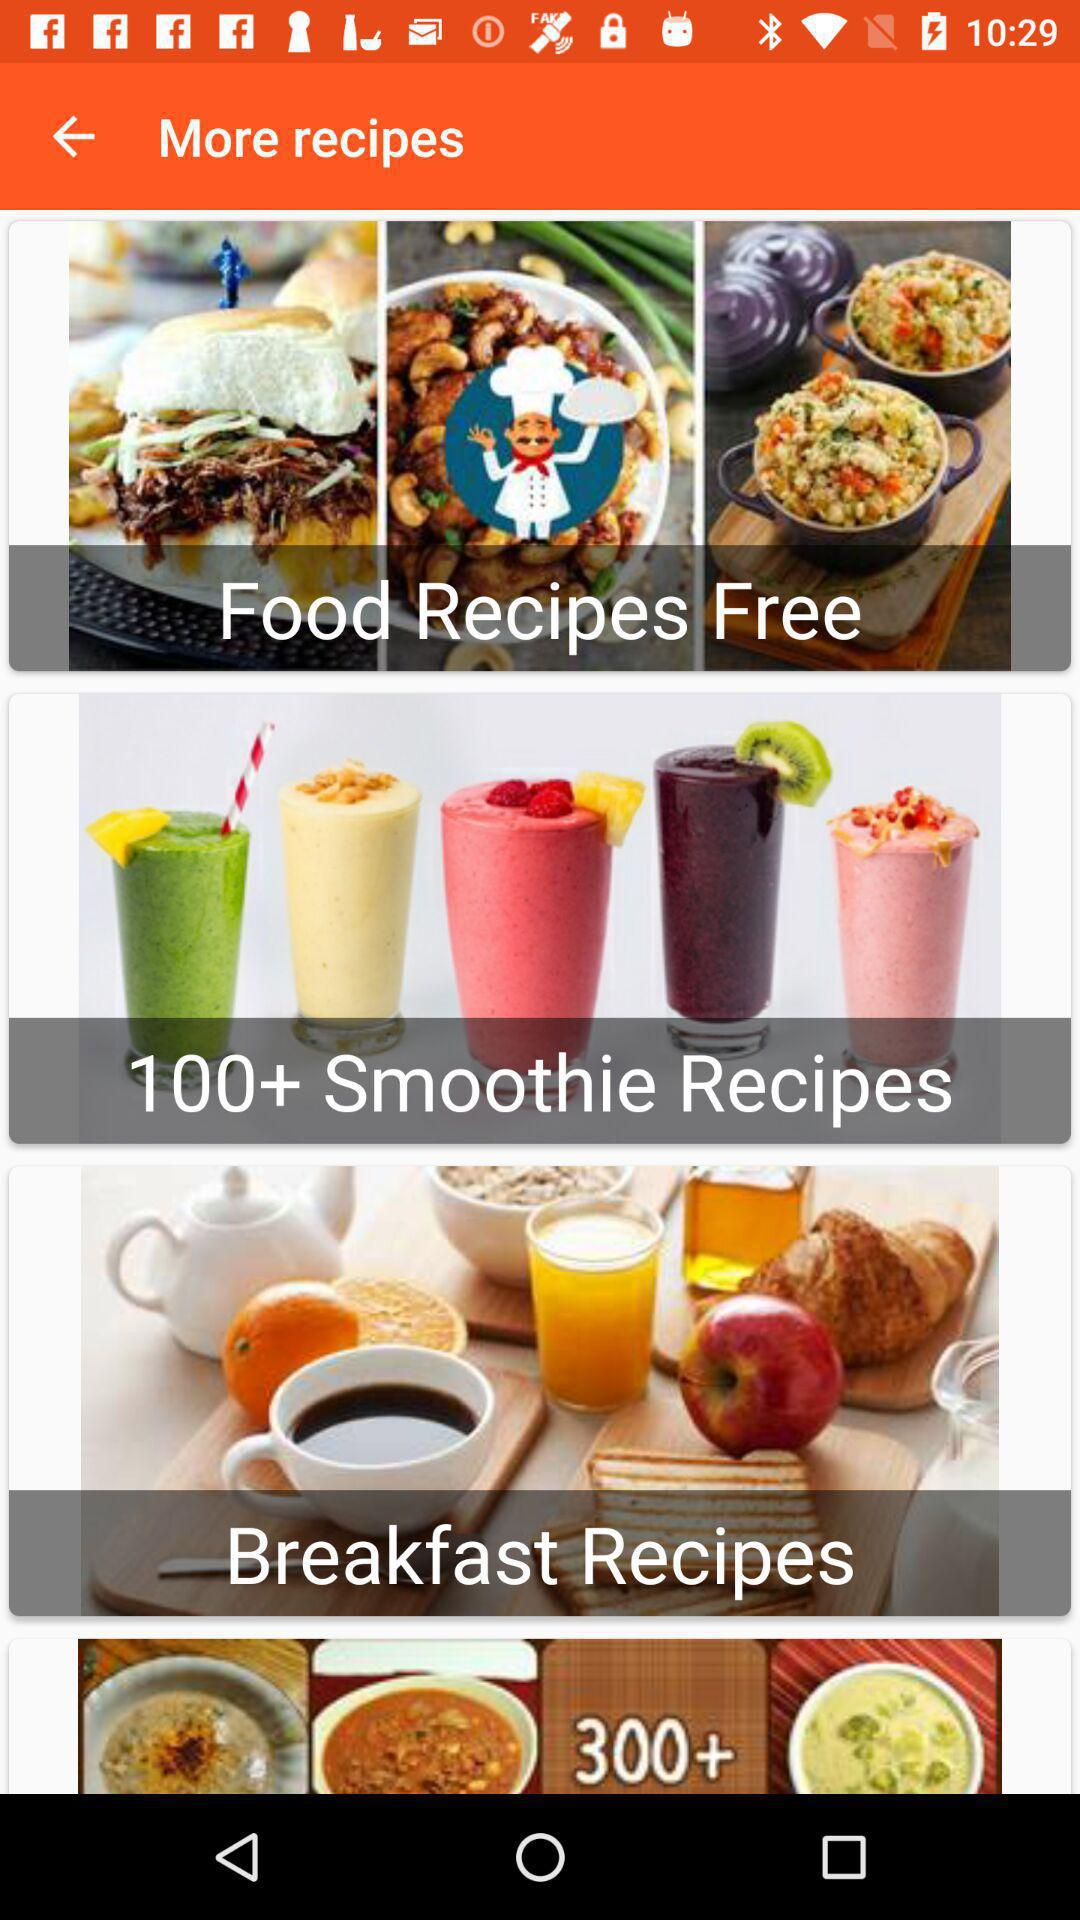How many breakfast recipes are there?
When the provided information is insufficient, respond with <no answer>. <no answer> 